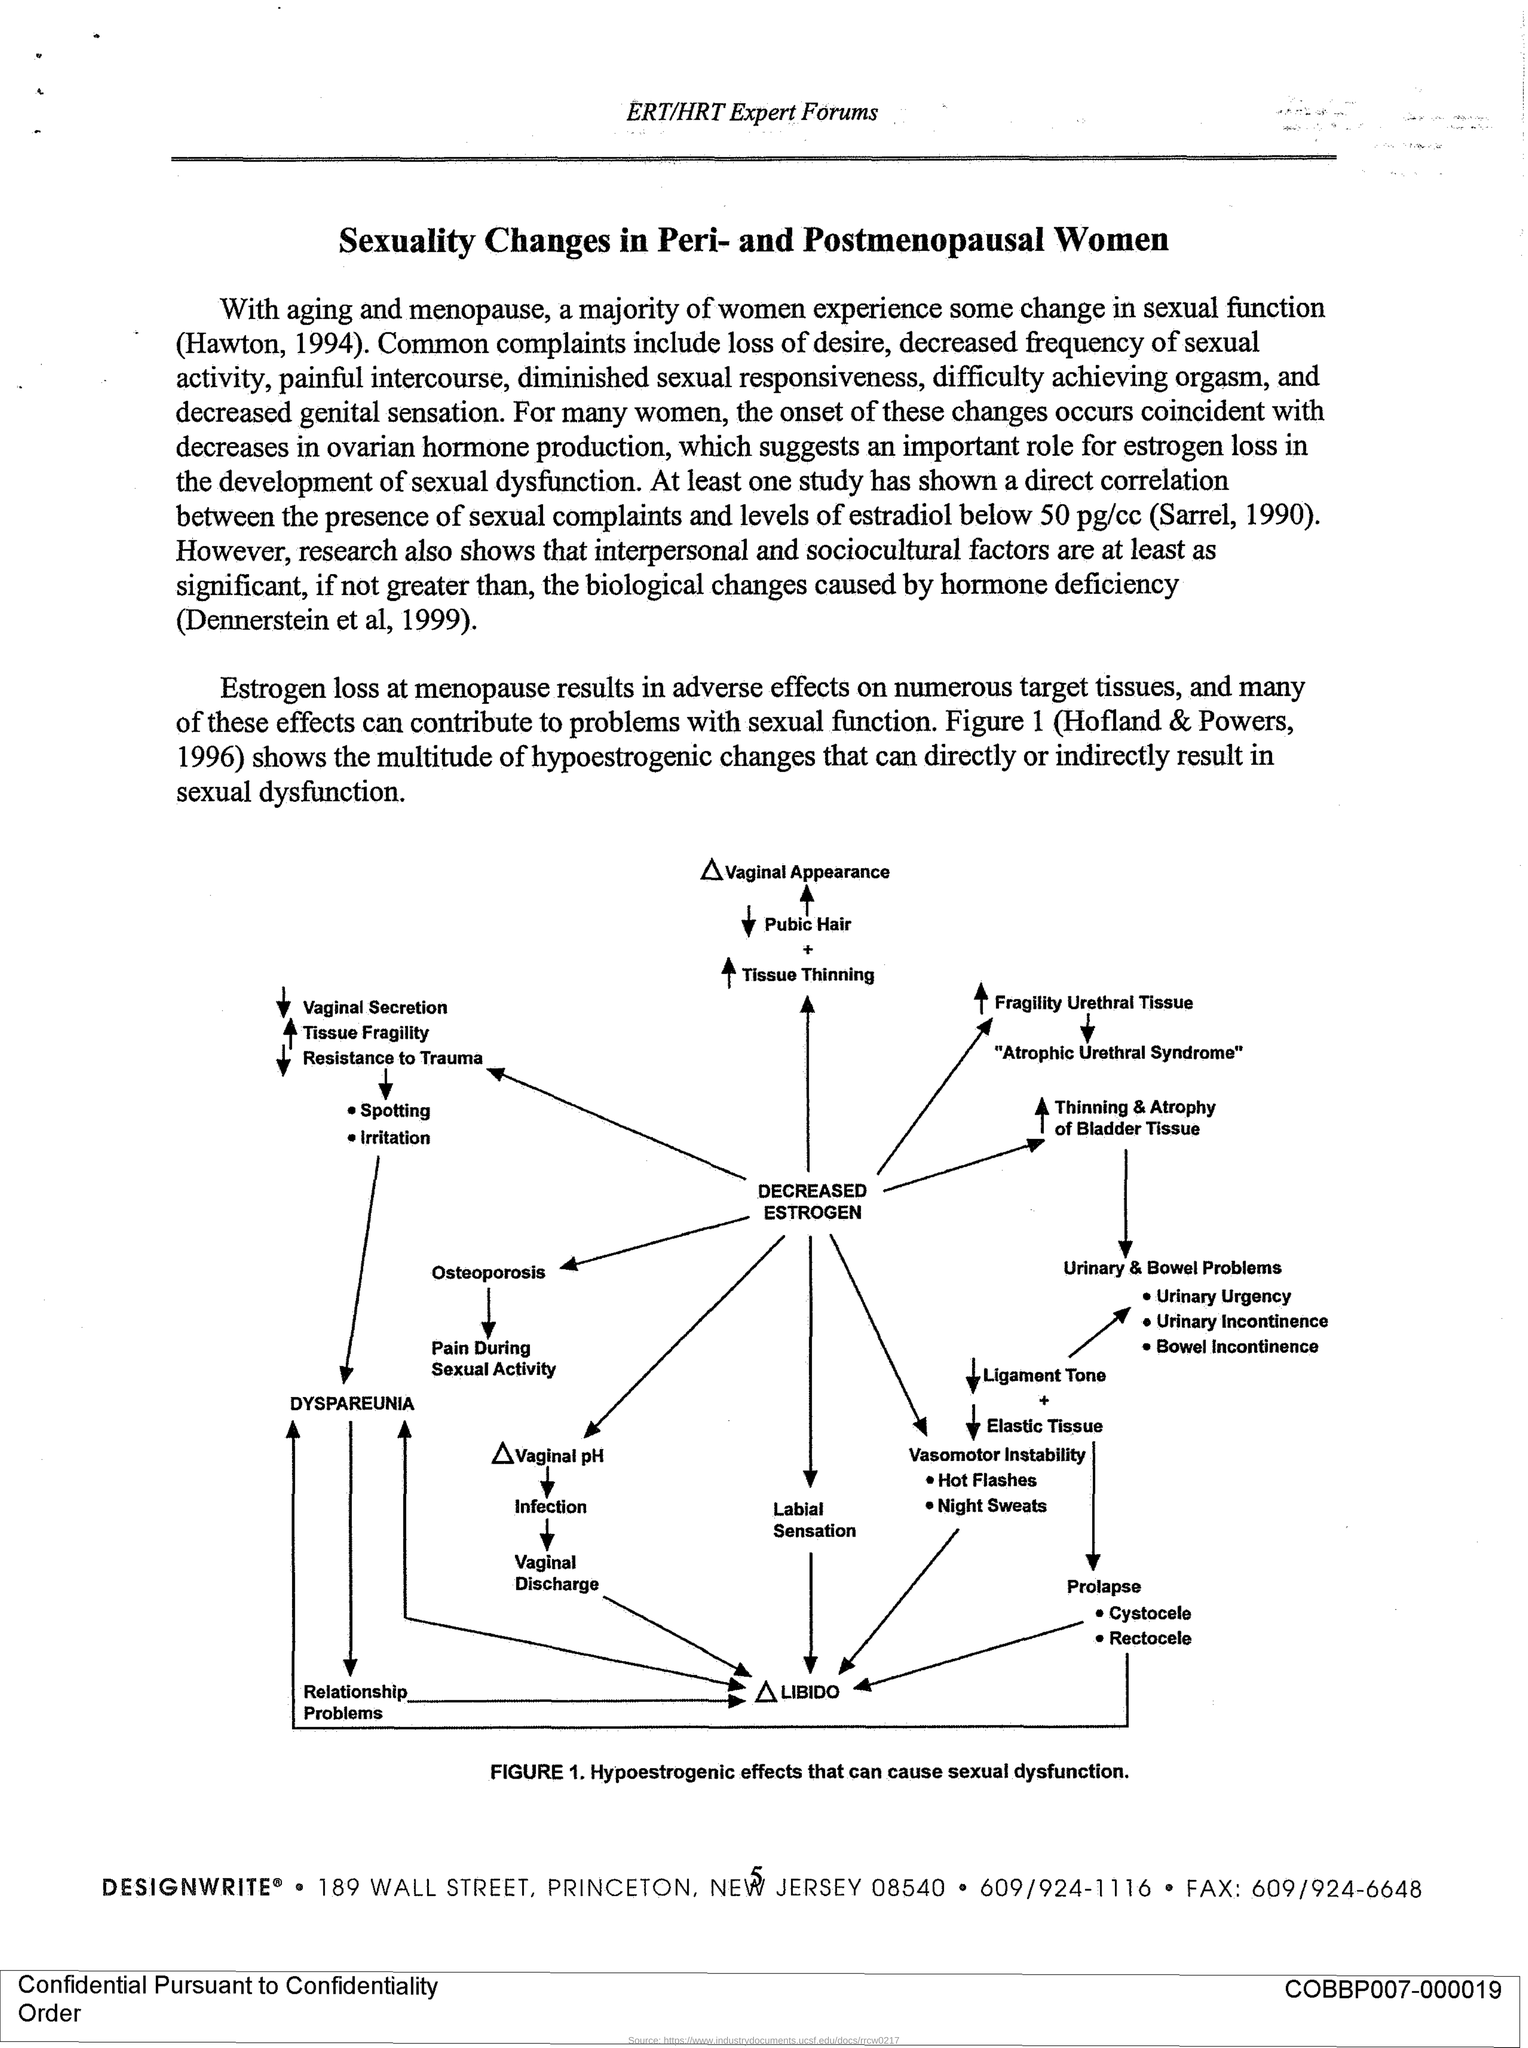Indicate a few pertinent items in this graphic. The fax number is 609/924-6648. The ZIP code is 08540. 